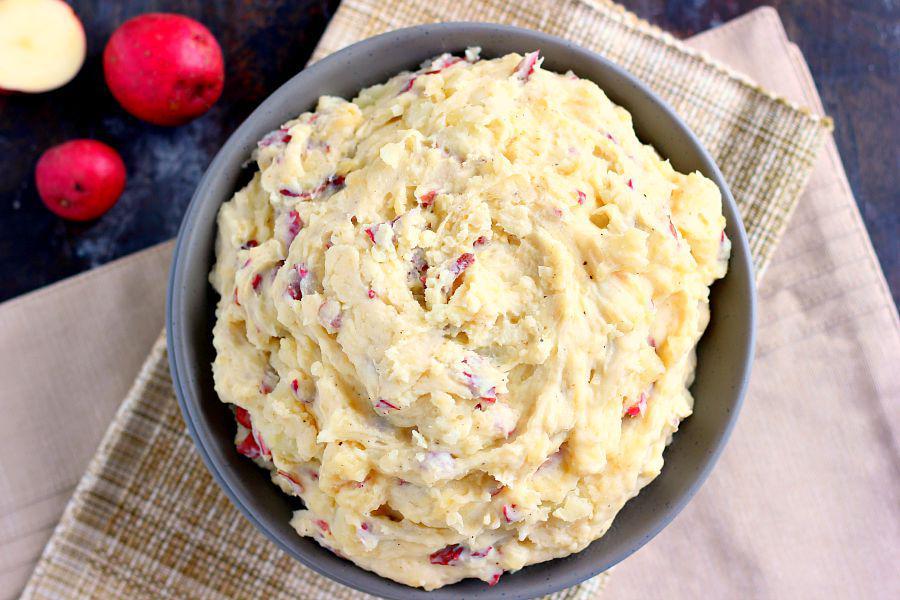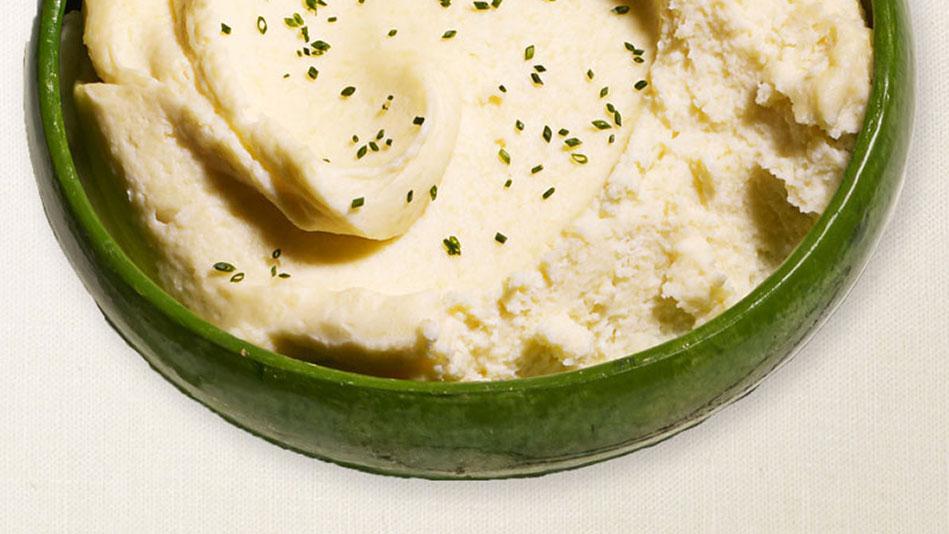The first image is the image on the left, the second image is the image on the right. Assess this claim about the two images: "One image shows potatoes garnished with green bits and served in a shiny olive green bowl.". Correct or not? Answer yes or no. Yes. The first image is the image on the left, the second image is the image on the right. Given the left and right images, does the statement "In one of the images, the mashed potatoes are in a green bowl." hold true? Answer yes or no. Yes. 